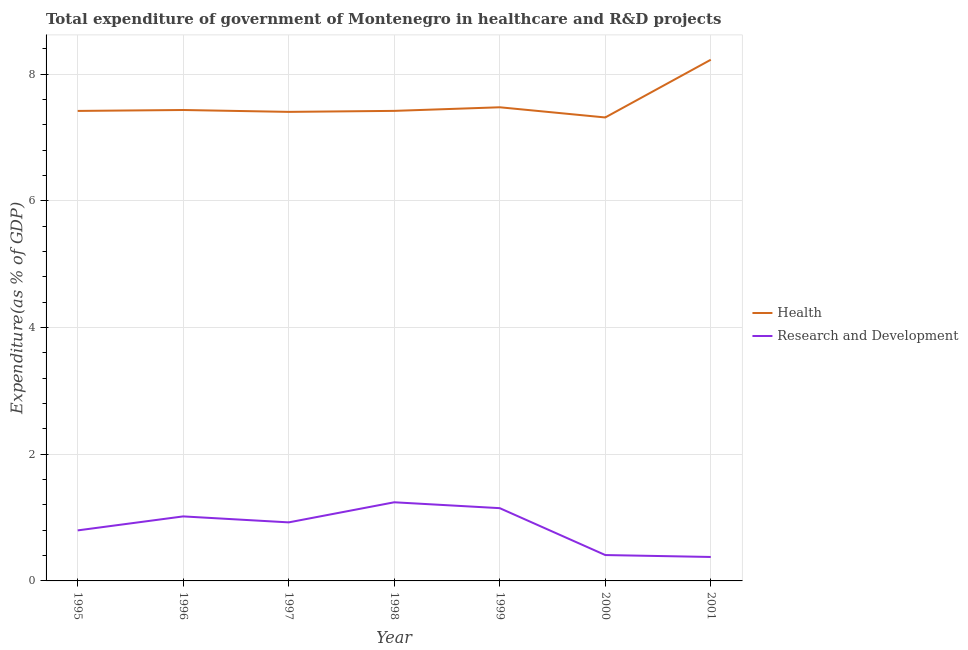How many different coloured lines are there?
Ensure brevity in your answer.  2. What is the expenditure in healthcare in 1995?
Offer a terse response. 7.42. Across all years, what is the maximum expenditure in r&d?
Ensure brevity in your answer.  1.24. Across all years, what is the minimum expenditure in healthcare?
Make the answer very short. 7.32. What is the total expenditure in r&d in the graph?
Your answer should be very brief. 5.92. What is the difference between the expenditure in r&d in 1996 and that in 1999?
Offer a very short reply. -0.13. What is the difference between the expenditure in healthcare in 1996 and the expenditure in r&d in 1997?
Provide a short and direct response. 6.51. What is the average expenditure in r&d per year?
Provide a short and direct response. 0.85. In the year 1997, what is the difference between the expenditure in r&d and expenditure in healthcare?
Offer a terse response. -6.48. What is the ratio of the expenditure in healthcare in 1999 to that in 2001?
Provide a succinct answer. 0.91. Is the difference between the expenditure in r&d in 1996 and 2000 greater than the difference between the expenditure in healthcare in 1996 and 2000?
Make the answer very short. Yes. What is the difference between the highest and the second highest expenditure in healthcare?
Ensure brevity in your answer.  0.75. What is the difference between the highest and the lowest expenditure in r&d?
Your answer should be compact. 0.86. In how many years, is the expenditure in r&d greater than the average expenditure in r&d taken over all years?
Your response must be concise. 4. Is the sum of the expenditure in healthcare in 1996 and 1999 greater than the maximum expenditure in r&d across all years?
Your answer should be compact. Yes. Does the expenditure in r&d monotonically increase over the years?
Provide a short and direct response. No. Is the expenditure in r&d strictly less than the expenditure in healthcare over the years?
Your response must be concise. Yes. What is the difference between two consecutive major ticks on the Y-axis?
Provide a succinct answer. 2. Does the graph contain grids?
Make the answer very short. Yes. What is the title of the graph?
Offer a terse response. Total expenditure of government of Montenegro in healthcare and R&D projects. Does "Females" appear as one of the legend labels in the graph?
Ensure brevity in your answer.  No. What is the label or title of the Y-axis?
Offer a very short reply. Expenditure(as % of GDP). What is the Expenditure(as % of GDP) in Health in 1995?
Provide a short and direct response. 7.42. What is the Expenditure(as % of GDP) of Research and Development in 1995?
Your answer should be compact. 0.8. What is the Expenditure(as % of GDP) of Health in 1996?
Provide a short and direct response. 7.44. What is the Expenditure(as % of GDP) of Research and Development in 1996?
Make the answer very short. 1.02. What is the Expenditure(as % of GDP) in Health in 1997?
Provide a short and direct response. 7.41. What is the Expenditure(as % of GDP) of Research and Development in 1997?
Offer a terse response. 0.92. What is the Expenditure(as % of GDP) in Health in 1998?
Provide a short and direct response. 7.42. What is the Expenditure(as % of GDP) of Research and Development in 1998?
Ensure brevity in your answer.  1.24. What is the Expenditure(as % of GDP) of Health in 1999?
Give a very brief answer. 7.48. What is the Expenditure(as % of GDP) of Research and Development in 1999?
Provide a succinct answer. 1.15. What is the Expenditure(as % of GDP) of Health in 2000?
Give a very brief answer. 7.32. What is the Expenditure(as % of GDP) in Research and Development in 2000?
Ensure brevity in your answer.  0.41. What is the Expenditure(as % of GDP) of Health in 2001?
Keep it short and to the point. 8.23. What is the Expenditure(as % of GDP) in Research and Development in 2001?
Keep it short and to the point. 0.38. Across all years, what is the maximum Expenditure(as % of GDP) of Health?
Your answer should be very brief. 8.23. Across all years, what is the maximum Expenditure(as % of GDP) of Research and Development?
Keep it short and to the point. 1.24. Across all years, what is the minimum Expenditure(as % of GDP) in Health?
Your answer should be very brief. 7.32. Across all years, what is the minimum Expenditure(as % of GDP) in Research and Development?
Offer a terse response. 0.38. What is the total Expenditure(as % of GDP) of Health in the graph?
Offer a very short reply. 52.71. What is the total Expenditure(as % of GDP) of Research and Development in the graph?
Offer a terse response. 5.92. What is the difference between the Expenditure(as % of GDP) in Health in 1995 and that in 1996?
Make the answer very short. -0.01. What is the difference between the Expenditure(as % of GDP) in Research and Development in 1995 and that in 1996?
Your answer should be very brief. -0.22. What is the difference between the Expenditure(as % of GDP) in Health in 1995 and that in 1997?
Provide a succinct answer. 0.01. What is the difference between the Expenditure(as % of GDP) of Research and Development in 1995 and that in 1997?
Your answer should be compact. -0.13. What is the difference between the Expenditure(as % of GDP) of Health in 1995 and that in 1998?
Provide a short and direct response. -0. What is the difference between the Expenditure(as % of GDP) of Research and Development in 1995 and that in 1998?
Offer a very short reply. -0.44. What is the difference between the Expenditure(as % of GDP) of Health in 1995 and that in 1999?
Your answer should be compact. -0.06. What is the difference between the Expenditure(as % of GDP) in Research and Development in 1995 and that in 1999?
Offer a very short reply. -0.35. What is the difference between the Expenditure(as % of GDP) of Health in 1995 and that in 2000?
Ensure brevity in your answer.  0.1. What is the difference between the Expenditure(as % of GDP) in Research and Development in 1995 and that in 2000?
Your answer should be very brief. 0.39. What is the difference between the Expenditure(as % of GDP) in Health in 1995 and that in 2001?
Your response must be concise. -0.81. What is the difference between the Expenditure(as % of GDP) of Research and Development in 1995 and that in 2001?
Your answer should be very brief. 0.42. What is the difference between the Expenditure(as % of GDP) in Health in 1996 and that in 1997?
Your answer should be compact. 0.03. What is the difference between the Expenditure(as % of GDP) in Research and Development in 1996 and that in 1997?
Your answer should be very brief. 0.09. What is the difference between the Expenditure(as % of GDP) in Health in 1996 and that in 1998?
Provide a succinct answer. 0.01. What is the difference between the Expenditure(as % of GDP) of Research and Development in 1996 and that in 1998?
Your answer should be very brief. -0.22. What is the difference between the Expenditure(as % of GDP) of Health in 1996 and that in 1999?
Your answer should be very brief. -0.04. What is the difference between the Expenditure(as % of GDP) of Research and Development in 1996 and that in 1999?
Offer a terse response. -0.13. What is the difference between the Expenditure(as % of GDP) of Health in 1996 and that in 2000?
Your answer should be very brief. 0.12. What is the difference between the Expenditure(as % of GDP) in Research and Development in 1996 and that in 2000?
Provide a short and direct response. 0.61. What is the difference between the Expenditure(as % of GDP) of Health in 1996 and that in 2001?
Provide a succinct answer. -0.79. What is the difference between the Expenditure(as % of GDP) of Research and Development in 1996 and that in 2001?
Give a very brief answer. 0.64. What is the difference between the Expenditure(as % of GDP) of Health in 1997 and that in 1998?
Make the answer very short. -0.02. What is the difference between the Expenditure(as % of GDP) in Research and Development in 1997 and that in 1998?
Offer a very short reply. -0.32. What is the difference between the Expenditure(as % of GDP) in Health in 1997 and that in 1999?
Make the answer very short. -0.07. What is the difference between the Expenditure(as % of GDP) of Research and Development in 1997 and that in 1999?
Offer a very short reply. -0.22. What is the difference between the Expenditure(as % of GDP) of Health in 1997 and that in 2000?
Offer a terse response. 0.09. What is the difference between the Expenditure(as % of GDP) of Research and Development in 1997 and that in 2000?
Your answer should be very brief. 0.52. What is the difference between the Expenditure(as % of GDP) in Health in 1997 and that in 2001?
Give a very brief answer. -0.82. What is the difference between the Expenditure(as % of GDP) in Research and Development in 1997 and that in 2001?
Your answer should be compact. 0.55. What is the difference between the Expenditure(as % of GDP) of Health in 1998 and that in 1999?
Ensure brevity in your answer.  -0.06. What is the difference between the Expenditure(as % of GDP) in Research and Development in 1998 and that in 1999?
Provide a short and direct response. 0.09. What is the difference between the Expenditure(as % of GDP) of Health in 1998 and that in 2000?
Provide a succinct answer. 0.1. What is the difference between the Expenditure(as % of GDP) of Research and Development in 1998 and that in 2000?
Ensure brevity in your answer.  0.83. What is the difference between the Expenditure(as % of GDP) of Health in 1998 and that in 2001?
Give a very brief answer. -0.81. What is the difference between the Expenditure(as % of GDP) in Research and Development in 1998 and that in 2001?
Offer a very short reply. 0.86. What is the difference between the Expenditure(as % of GDP) of Health in 1999 and that in 2000?
Offer a terse response. 0.16. What is the difference between the Expenditure(as % of GDP) of Research and Development in 1999 and that in 2000?
Make the answer very short. 0.74. What is the difference between the Expenditure(as % of GDP) of Health in 1999 and that in 2001?
Your response must be concise. -0.75. What is the difference between the Expenditure(as % of GDP) in Research and Development in 1999 and that in 2001?
Make the answer very short. 0.77. What is the difference between the Expenditure(as % of GDP) of Health in 2000 and that in 2001?
Your answer should be very brief. -0.91. What is the difference between the Expenditure(as % of GDP) of Research and Development in 2000 and that in 2001?
Offer a terse response. 0.03. What is the difference between the Expenditure(as % of GDP) in Health in 1995 and the Expenditure(as % of GDP) in Research and Development in 1996?
Keep it short and to the point. 6.4. What is the difference between the Expenditure(as % of GDP) of Health in 1995 and the Expenditure(as % of GDP) of Research and Development in 1997?
Give a very brief answer. 6.5. What is the difference between the Expenditure(as % of GDP) of Health in 1995 and the Expenditure(as % of GDP) of Research and Development in 1998?
Keep it short and to the point. 6.18. What is the difference between the Expenditure(as % of GDP) in Health in 1995 and the Expenditure(as % of GDP) in Research and Development in 1999?
Your response must be concise. 6.27. What is the difference between the Expenditure(as % of GDP) in Health in 1995 and the Expenditure(as % of GDP) in Research and Development in 2000?
Provide a succinct answer. 7.01. What is the difference between the Expenditure(as % of GDP) in Health in 1995 and the Expenditure(as % of GDP) in Research and Development in 2001?
Provide a succinct answer. 7.04. What is the difference between the Expenditure(as % of GDP) of Health in 1996 and the Expenditure(as % of GDP) of Research and Development in 1997?
Your answer should be very brief. 6.51. What is the difference between the Expenditure(as % of GDP) of Health in 1996 and the Expenditure(as % of GDP) of Research and Development in 1998?
Provide a succinct answer. 6.19. What is the difference between the Expenditure(as % of GDP) of Health in 1996 and the Expenditure(as % of GDP) of Research and Development in 1999?
Offer a terse response. 6.29. What is the difference between the Expenditure(as % of GDP) of Health in 1996 and the Expenditure(as % of GDP) of Research and Development in 2000?
Provide a succinct answer. 7.03. What is the difference between the Expenditure(as % of GDP) of Health in 1996 and the Expenditure(as % of GDP) of Research and Development in 2001?
Your answer should be compact. 7.06. What is the difference between the Expenditure(as % of GDP) of Health in 1997 and the Expenditure(as % of GDP) of Research and Development in 1998?
Keep it short and to the point. 6.16. What is the difference between the Expenditure(as % of GDP) in Health in 1997 and the Expenditure(as % of GDP) in Research and Development in 1999?
Make the answer very short. 6.26. What is the difference between the Expenditure(as % of GDP) of Health in 1997 and the Expenditure(as % of GDP) of Research and Development in 2000?
Offer a terse response. 7. What is the difference between the Expenditure(as % of GDP) in Health in 1997 and the Expenditure(as % of GDP) in Research and Development in 2001?
Provide a succinct answer. 7.03. What is the difference between the Expenditure(as % of GDP) in Health in 1998 and the Expenditure(as % of GDP) in Research and Development in 1999?
Provide a short and direct response. 6.27. What is the difference between the Expenditure(as % of GDP) in Health in 1998 and the Expenditure(as % of GDP) in Research and Development in 2000?
Make the answer very short. 7.01. What is the difference between the Expenditure(as % of GDP) in Health in 1998 and the Expenditure(as % of GDP) in Research and Development in 2001?
Offer a terse response. 7.04. What is the difference between the Expenditure(as % of GDP) in Health in 1999 and the Expenditure(as % of GDP) in Research and Development in 2000?
Your answer should be compact. 7.07. What is the difference between the Expenditure(as % of GDP) of Health in 1999 and the Expenditure(as % of GDP) of Research and Development in 2001?
Keep it short and to the point. 7.1. What is the difference between the Expenditure(as % of GDP) of Health in 2000 and the Expenditure(as % of GDP) of Research and Development in 2001?
Provide a short and direct response. 6.94. What is the average Expenditure(as % of GDP) in Health per year?
Your response must be concise. 7.53. What is the average Expenditure(as % of GDP) in Research and Development per year?
Make the answer very short. 0.85. In the year 1995, what is the difference between the Expenditure(as % of GDP) in Health and Expenditure(as % of GDP) in Research and Development?
Your answer should be compact. 6.62. In the year 1996, what is the difference between the Expenditure(as % of GDP) of Health and Expenditure(as % of GDP) of Research and Development?
Provide a succinct answer. 6.42. In the year 1997, what is the difference between the Expenditure(as % of GDP) in Health and Expenditure(as % of GDP) in Research and Development?
Offer a terse response. 6.48. In the year 1998, what is the difference between the Expenditure(as % of GDP) of Health and Expenditure(as % of GDP) of Research and Development?
Give a very brief answer. 6.18. In the year 1999, what is the difference between the Expenditure(as % of GDP) in Health and Expenditure(as % of GDP) in Research and Development?
Your answer should be compact. 6.33. In the year 2000, what is the difference between the Expenditure(as % of GDP) of Health and Expenditure(as % of GDP) of Research and Development?
Keep it short and to the point. 6.91. In the year 2001, what is the difference between the Expenditure(as % of GDP) in Health and Expenditure(as % of GDP) in Research and Development?
Provide a short and direct response. 7.85. What is the ratio of the Expenditure(as % of GDP) of Health in 1995 to that in 1996?
Keep it short and to the point. 1. What is the ratio of the Expenditure(as % of GDP) in Research and Development in 1995 to that in 1996?
Make the answer very short. 0.78. What is the ratio of the Expenditure(as % of GDP) of Health in 1995 to that in 1997?
Your response must be concise. 1. What is the ratio of the Expenditure(as % of GDP) in Research and Development in 1995 to that in 1997?
Give a very brief answer. 0.86. What is the ratio of the Expenditure(as % of GDP) in Health in 1995 to that in 1998?
Your answer should be compact. 1. What is the ratio of the Expenditure(as % of GDP) in Research and Development in 1995 to that in 1998?
Offer a very short reply. 0.64. What is the ratio of the Expenditure(as % of GDP) in Health in 1995 to that in 1999?
Keep it short and to the point. 0.99. What is the ratio of the Expenditure(as % of GDP) in Research and Development in 1995 to that in 1999?
Provide a succinct answer. 0.69. What is the ratio of the Expenditure(as % of GDP) of Health in 1995 to that in 2000?
Ensure brevity in your answer.  1.01. What is the ratio of the Expenditure(as % of GDP) of Research and Development in 1995 to that in 2000?
Keep it short and to the point. 1.95. What is the ratio of the Expenditure(as % of GDP) in Health in 1995 to that in 2001?
Keep it short and to the point. 0.9. What is the ratio of the Expenditure(as % of GDP) in Research and Development in 1995 to that in 2001?
Ensure brevity in your answer.  2.11. What is the ratio of the Expenditure(as % of GDP) in Research and Development in 1996 to that in 1997?
Your response must be concise. 1.1. What is the ratio of the Expenditure(as % of GDP) of Health in 1996 to that in 1998?
Your response must be concise. 1. What is the ratio of the Expenditure(as % of GDP) of Research and Development in 1996 to that in 1998?
Offer a terse response. 0.82. What is the ratio of the Expenditure(as % of GDP) in Health in 1996 to that in 1999?
Your answer should be very brief. 0.99. What is the ratio of the Expenditure(as % of GDP) of Research and Development in 1996 to that in 1999?
Your response must be concise. 0.89. What is the ratio of the Expenditure(as % of GDP) in Health in 1996 to that in 2000?
Your answer should be compact. 1.02. What is the ratio of the Expenditure(as % of GDP) of Research and Development in 1996 to that in 2000?
Your answer should be very brief. 2.49. What is the ratio of the Expenditure(as % of GDP) in Health in 1996 to that in 2001?
Your answer should be compact. 0.9. What is the ratio of the Expenditure(as % of GDP) of Research and Development in 1996 to that in 2001?
Provide a succinct answer. 2.69. What is the ratio of the Expenditure(as % of GDP) in Health in 1997 to that in 1998?
Provide a short and direct response. 1. What is the ratio of the Expenditure(as % of GDP) in Research and Development in 1997 to that in 1998?
Make the answer very short. 0.74. What is the ratio of the Expenditure(as % of GDP) in Health in 1997 to that in 1999?
Ensure brevity in your answer.  0.99. What is the ratio of the Expenditure(as % of GDP) in Research and Development in 1997 to that in 1999?
Provide a succinct answer. 0.8. What is the ratio of the Expenditure(as % of GDP) in Health in 1997 to that in 2000?
Your answer should be compact. 1.01. What is the ratio of the Expenditure(as % of GDP) in Research and Development in 1997 to that in 2000?
Make the answer very short. 2.26. What is the ratio of the Expenditure(as % of GDP) in Research and Development in 1997 to that in 2001?
Your answer should be compact. 2.44. What is the ratio of the Expenditure(as % of GDP) of Health in 1998 to that in 1999?
Your answer should be compact. 0.99. What is the ratio of the Expenditure(as % of GDP) of Research and Development in 1998 to that in 1999?
Give a very brief answer. 1.08. What is the ratio of the Expenditure(as % of GDP) in Health in 1998 to that in 2000?
Provide a short and direct response. 1.01. What is the ratio of the Expenditure(as % of GDP) of Research and Development in 1998 to that in 2000?
Your answer should be compact. 3.04. What is the ratio of the Expenditure(as % of GDP) of Health in 1998 to that in 2001?
Make the answer very short. 0.9. What is the ratio of the Expenditure(as % of GDP) of Research and Development in 1998 to that in 2001?
Your answer should be very brief. 3.28. What is the ratio of the Expenditure(as % of GDP) in Research and Development in 1999 to that in 2000?
Provide a short and direct response. 2.81. What is the ratio of the Expenditure(as % of GDP) of Health in 1999 to that in 2001?
Your answer should be very brief. 0.91. What is the ratio of the Expenditure(as % of GDP) in Research and Development in 1999 to that in 2001?
Your answer should be compact. 3.04. What is the ratio of the Expenditure(as % of GDP) in Health in 2000 to that in 2001?
Make the answer very short. 0.89. What is the ratio of the Expenditure(as % of GDP) in Research and Development in 2000 to that in 2001?
Provide a succinct answer. 1.08. What is the difference between the highest and the second highest Expenditure(as % of GDP) in Health?
Your answer should be compact. 0.75. What is the difference between the highest and the second highest Expenditure(as % of GDP) in Research and Development?
Your answer should be very brief. 0.09. What is the difference between the highest and the lowest Expenditure(as % of GDP) of Health?
Your answer should be compact. 0.91. What is the difference between the highest and the lowest Expenditure(as % of GDP) of Research and Development?
Your answer should be compact. 0.86. 